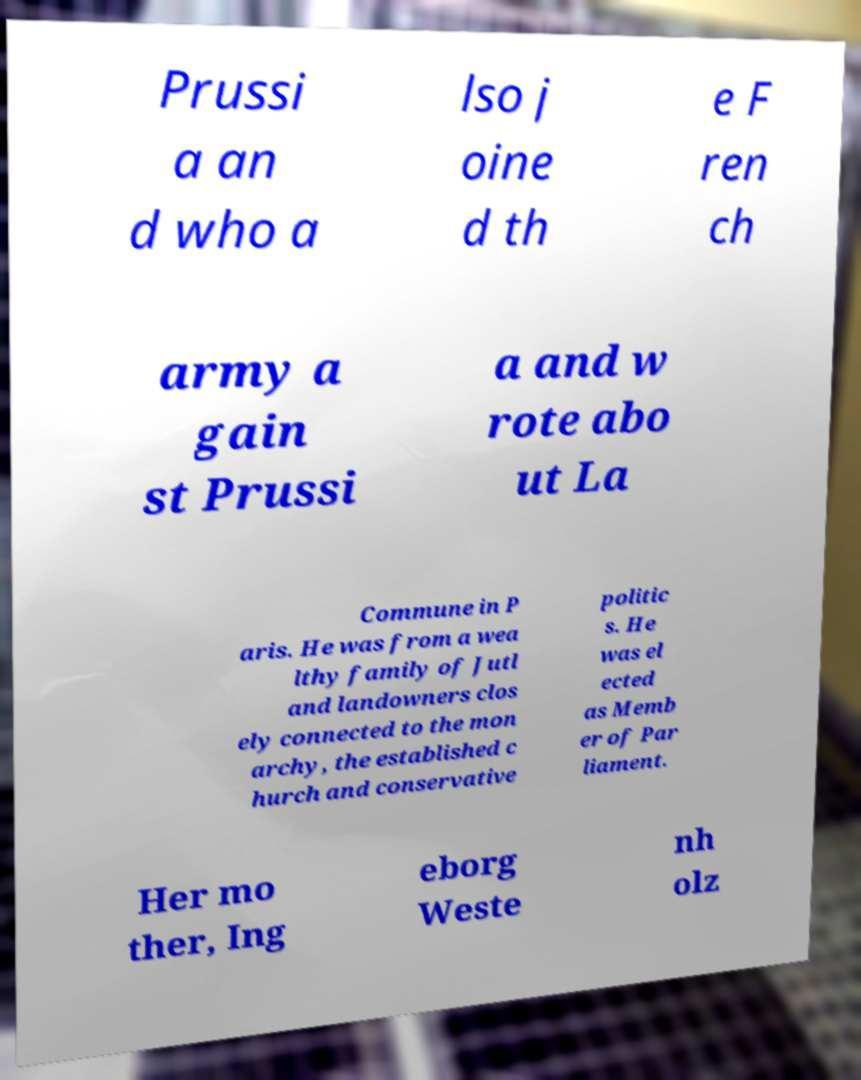Could you assist in decoding the text presented in this image and type it out clearly? Prussi a an d who a lso j oine d th e F ren ch army a gain st Prussi a and w rote abo ut La Commune in P aris. He was from a wea lthy family of Jutl and landowners clos ely connected to the mon archy, the established c hurch and conservative politic s. He was el ected as Memb er of Par liament. Her mo ther, Ing eborg Weste nh olz 